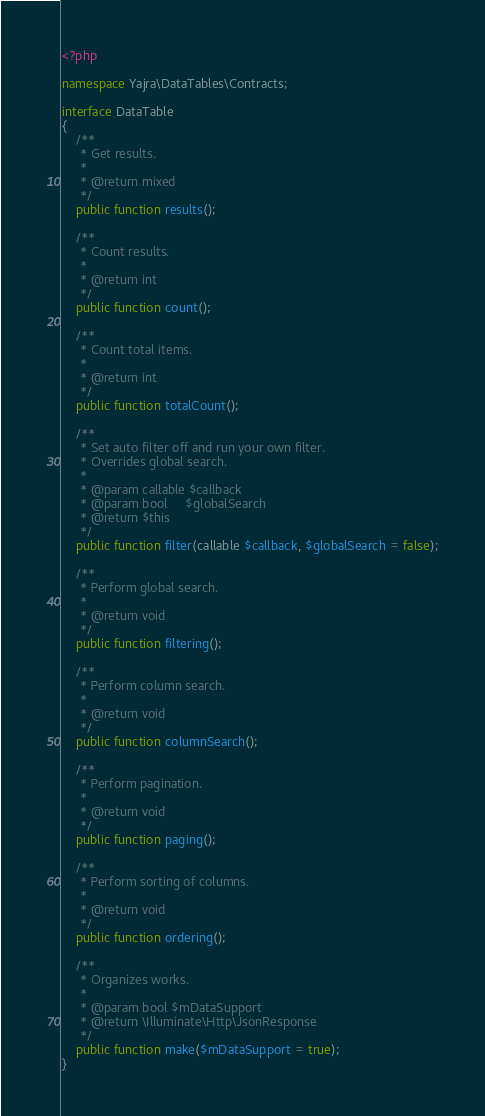Convert code to text. <code><loc_0><loc_0><loc_500><loc_500><_PHP_><?php

namespace Yajra\DataTables\Contracts;

interface DataTable
{
    /**
     * Get results.
     *
     * @return mixed
     */
    public function results();

    /**
     * Count results.
     *
     * @return int
     */
    public function count();

    /**
     * Count total items.
     *
     * @return int
     */
    public function totalCount();

    /**
     * Set auto filter off and run your own filter.
     * Overrides global search.
     *
     * @param callable $callback
     * @param bool     $globalSearch
     * @return $this
     */
    public function filter(callable $callback, $globalSearch = false);

    /**
     * Perform global search.
     *
     * @return void
     */
    public function filtering();

    /**
     * Perform column search.
     *
     * @return void
     */
    public function columnSearch();

    /**
     * Perform pagination.
     *
     * @return void
     */
    public function paging();

    /**
     * Perform sorting of columns.
     *
     * @return void
     */
    public function ordering();

    /**
     * Organizes works.
     *
     * @param bool $mDataSupport
     * @return \Illuminate\Http\JsonResponse
     */
    public function make($mDataSupport = true);
}
</code> 